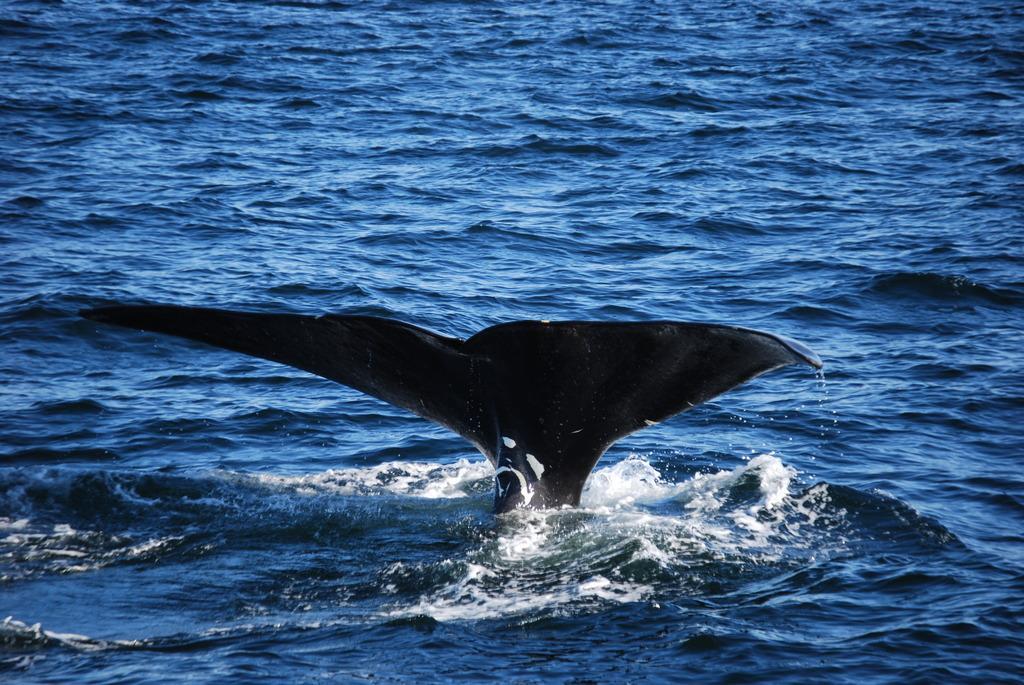Please provide a concise description of this image. In the picture we can see a fishtail which is black in color in the water which is blue in color. 